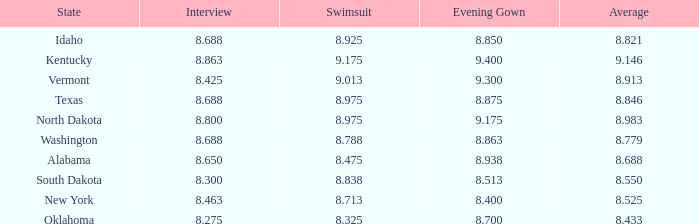275 interview score and an evening gown score exceeding None. 